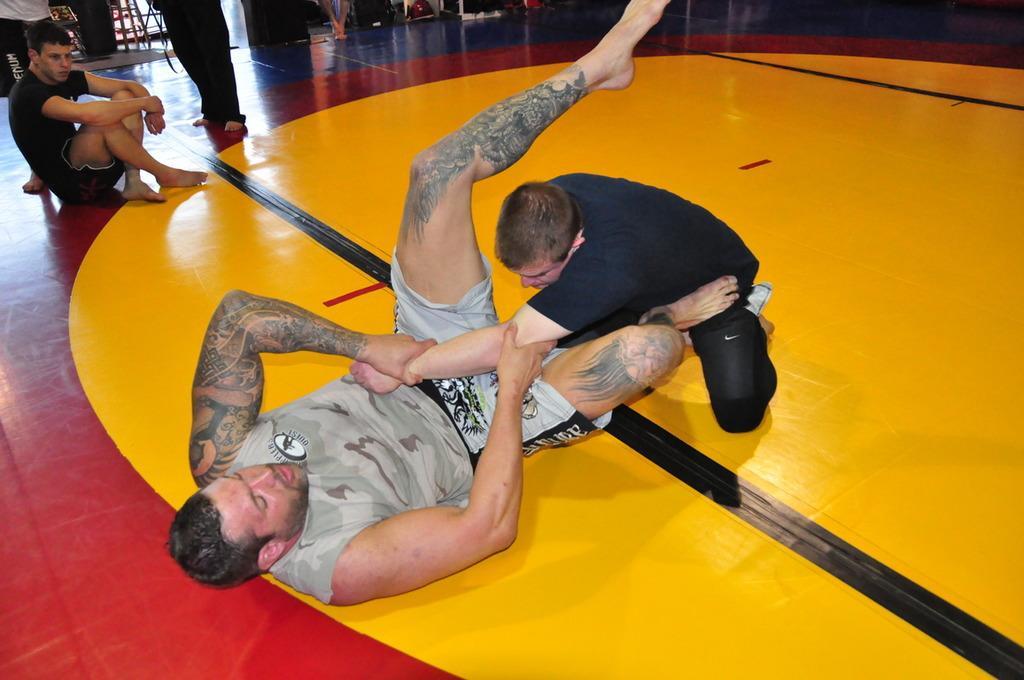In one or two sentences, can you explain what this image depicts? In this image we can see people, floor, and other objects. 